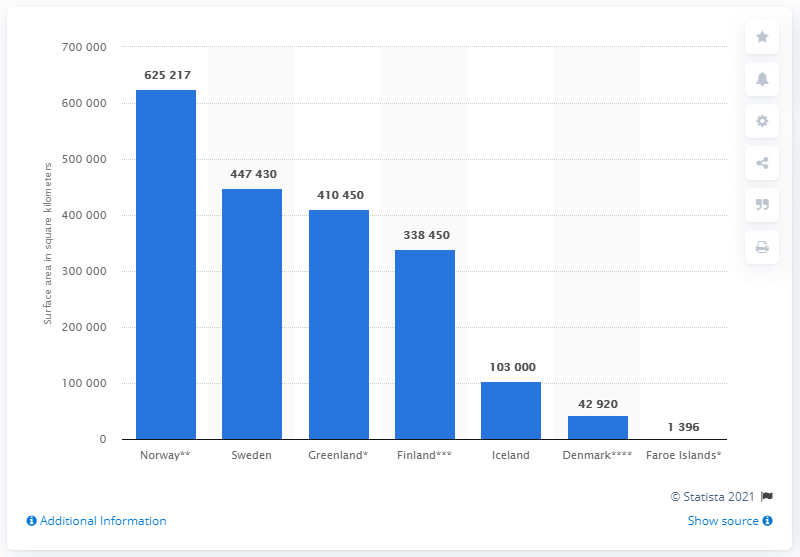Point out several critical features in this image. The surface area of Greenland is approximately 410,450 square kilometers. Sweden's surface area is approximately 447,430 square kilometers. Iceland's total surface area is approximately 103,000 square kilometers. Norway has a surface area of approximately 625,217 square kilometers. The surface area of Denmark is approximately 42,920 square kilometers. 